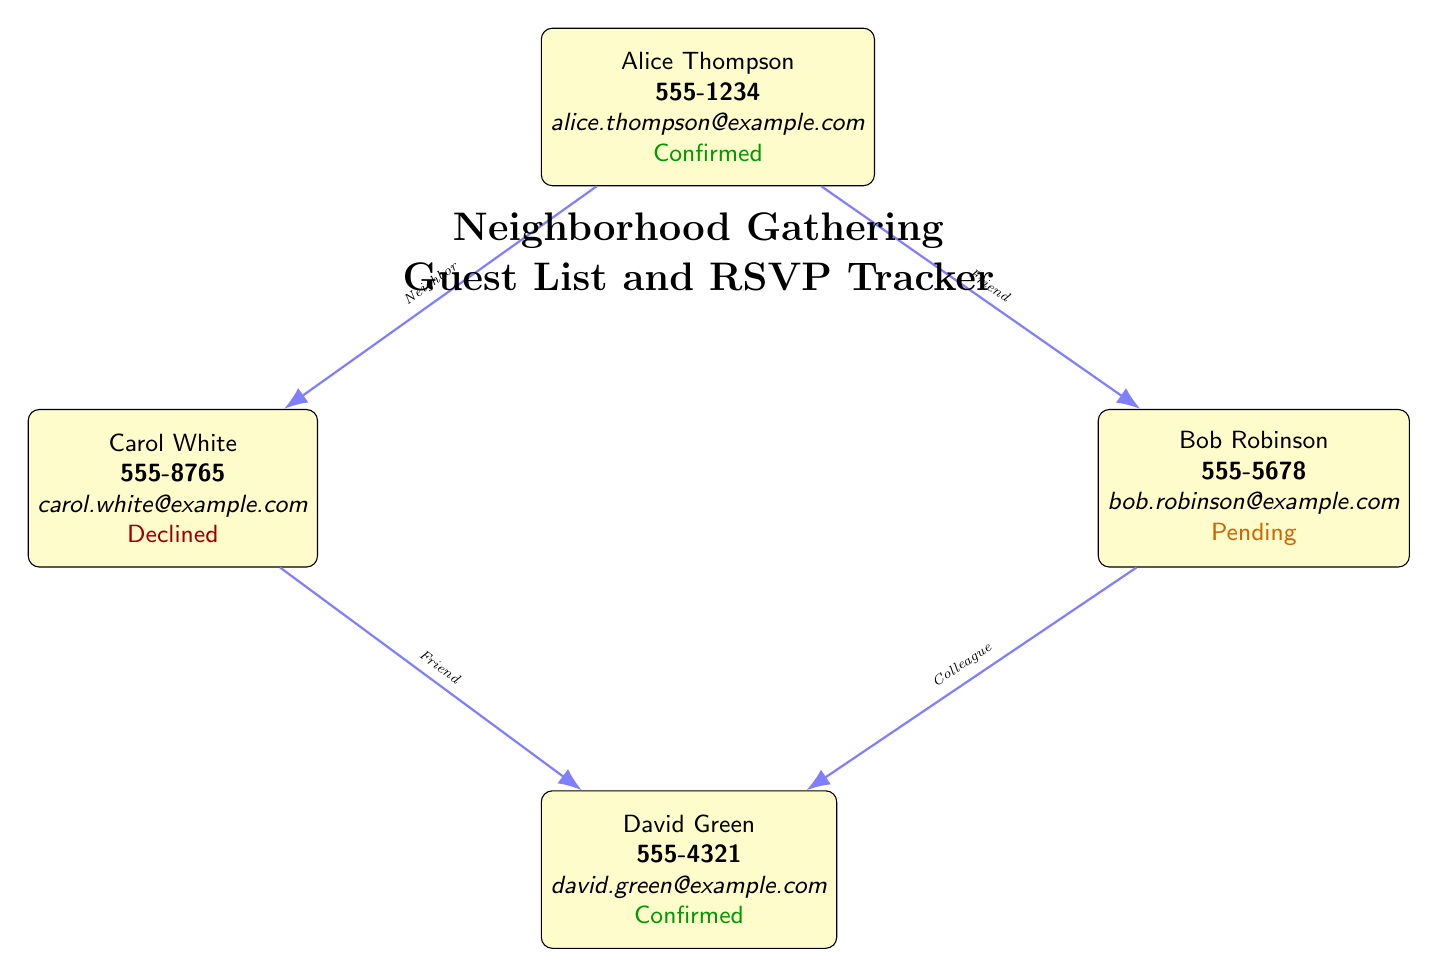What is the attendance status of David Green? The node for David Green is checked in the diagram, which states his attendance status as "Confirmed".
Answer: Confirmed How many guests are listed in the diagram? There are four nodes representing guests: Alice, Bob, Carol, and David. Therefore, the total number of guests is four.
Answer: 4 What is Carol White's contact email? The information in Carol White's node shows her contact email listed as "carol.white@example.com".
Answer: carol.white@example.com What type of connection exists between Alice and Bob? The edge connecting Alice and Bob is labeled as "Friend", which indicates the type of relationship between them.
Answer: Friend Who declined the invitation? The node for Carol White is clearly marked with the status "Declined", indicating that she is the guest who declined the invitation.
Answer: Carol White What color represents confirmed guests in the diagram? The nodes of confirmed guests, such as Alice and David, use the color green which indicates their status.
Answer: Green How are Bob and David connected in the diagram? There is a direct connection between Bob and David, labeled as "Colleague", describing their relationship.
Answer: Colleague Which guest has a pending RSVP status? The node for Bob Robinson clearly indicates "Pending" for his attendance status.
Answer: Bob Robinson What is the title of the diagram? The title of the diagram is displayed prominently above the guest list as "Neighborhood Gathering Guest List and RSVP Tracker".
Answer: Neighborhood Gathering Guest List and RSVP Tracker 